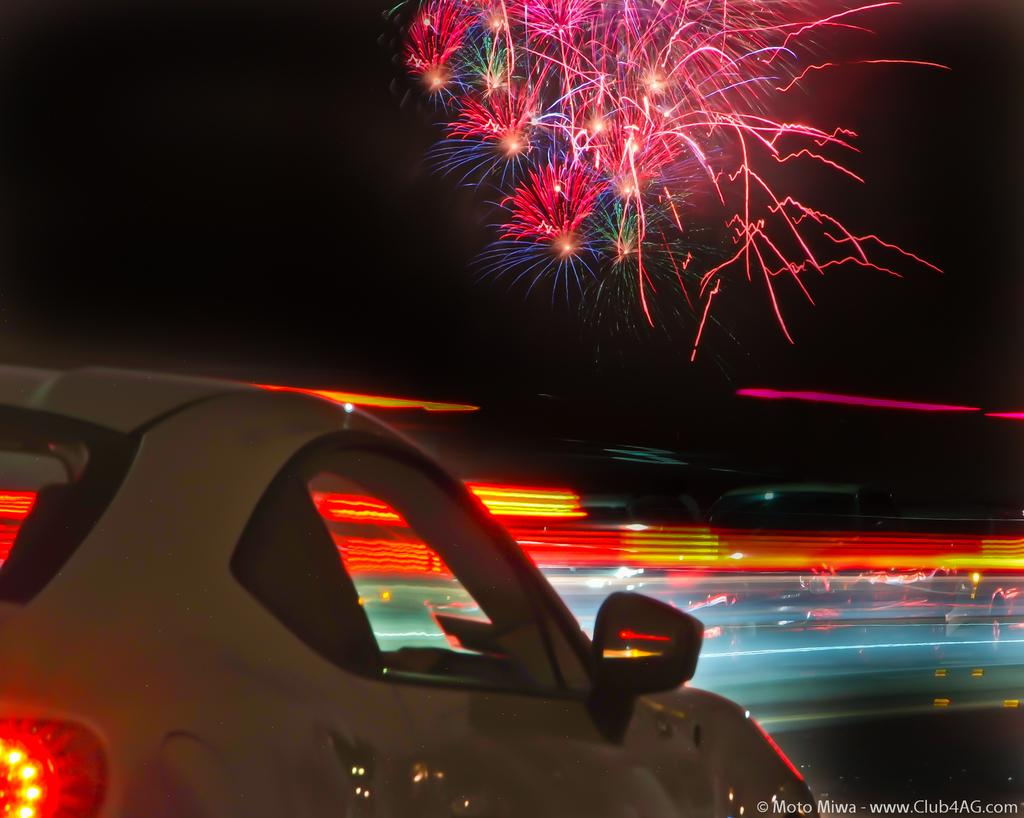What is happening with the crackers in the image? The crackers are lighting in the image. What else can be seen happening in the image? There are vehicles moving on the road in the image. What part of the goldfish is visible in the image? There is no goldfish present in the image. How does the goldfish run in the image? There is no goldfish present in the image, so it cannot run. 